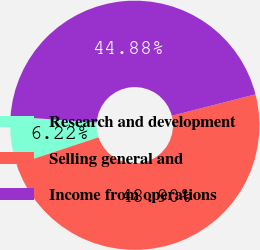Convert chart to OTSL. <chart><loc_0><loc_0><loc_500><loc_500><pie_chart><fcel>Research and development<fcel>Selling general and<fcel>Income from operations<nl><fcel>6.22%<fcel>48.9%<fcel>44.88%<nl></chart> 